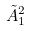Convert formula to latex. <formula><loc_0><loc_0><loc_500><loc_500>\tilde { A } _ { 1 } ^ { 2 }</formula> 